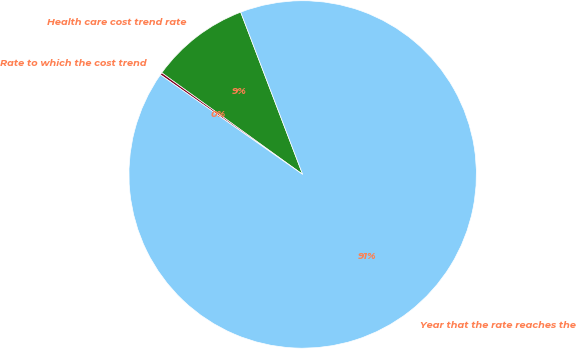<chart> <loc_0><loc_0><loc_500><loc_500><pie_chart><fcel>Health care cost trend rate<fcel>Rate to which the cost trend<fcel>Year that the rate reaches the<nl><fcel>9.25%<fcel>0.22%<fcel>90.52%<nl></chart> 